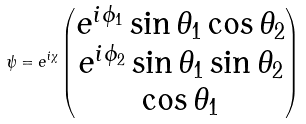Convert formula to latex. <formula><loc_0><loc_0><loc_500><loc_500>\psi = e ^ { i \chi } \left ( \begin{matrix} e ^ { i \phi _ { 1 } } \sin { \theta _ { 1 } } \cos { \theta _ { 2 } } \\ e ^ { i \phi _ { 2 } } \sin { \theta _ { 1 } } \sin { \theta _ { 2 } } \\ \cos { \theta _ { 1 } } \\ \end{matrix} \right )</formula> 